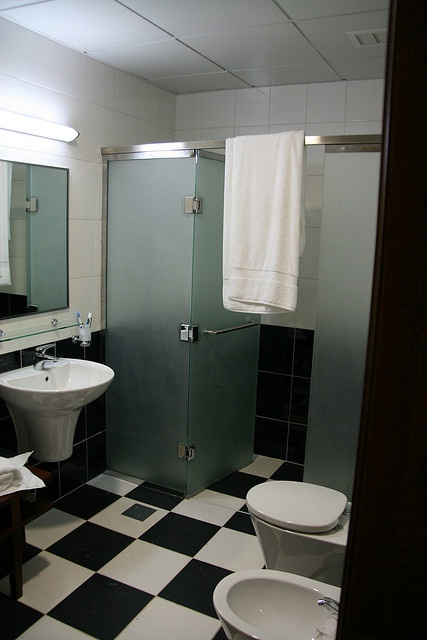Describe the objects in this image and their specific colors. I can see toilet in lightgray, darkgray, black, and gray tones, sink in lightgray and darkgray tones, and toothbrush in lightgray, darkgray, gray, and blue tones in this image. 